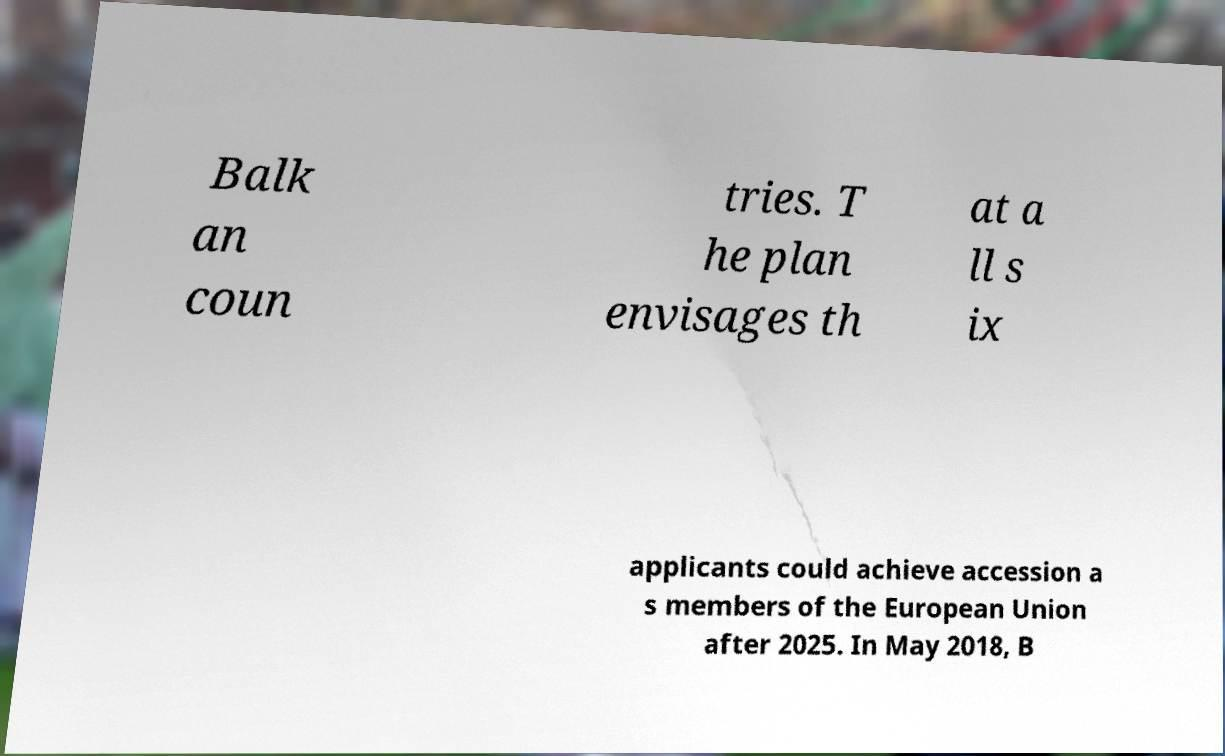Can you accurately transcribe the text from the provided image for me? Balk an coun tries. T he plan envisages th at a ll s ix applicants could achieve accession a s members of the European Union after 2025. In May 2018, B 